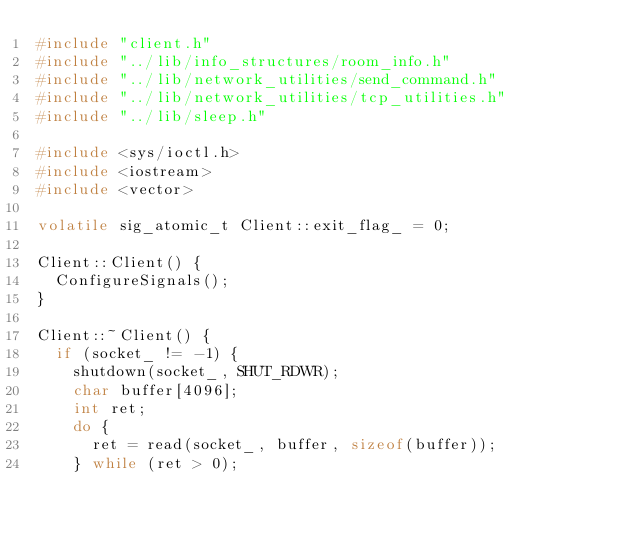Convert code to text. <code><loc_0><loc_0><loc_500><loc_500><_C++_>#include "client.h"
#include "../lib/info_structures/room_info.h"
#include "../lib/network_utilities/send_command.h"
#include "../lib/network_utilities/tcp_utilities.h"
#include "../lib/sleep.h"

#include <sys/ioctl.h>
#include <iostream>
#include <vector>

volatile sig_atomic_t Client::exit_flag_ = 0;

Client::Client() {
  ConfigureSignals();
}

Client::~Client() {
  if (socket_ != -1) {
    shutdown(socket_, SHUT_RDWR);
    char buffer[4096];
    int ret;
    do {
      ret = read(socket_, buffer, sizeof(buffer));
    } while (ret > 0);</code> 